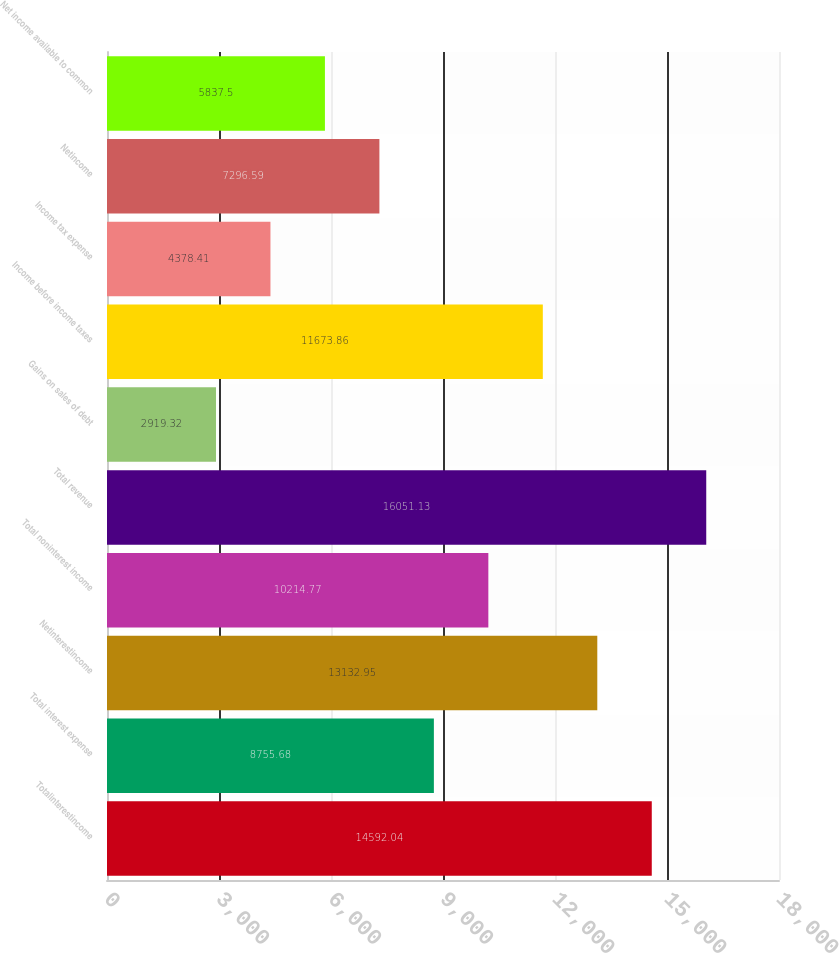Convert chart to OTSL. <chart><loc_0><loc_0><loc_500><loc_500><bar_chart><fcel>Totalinterestincome<fcel>Total interest expense<fcel>Netinterestincome<fcel>Total noninterest income<fcel>Total revenue<fcel>Gains on sales of debt<fcel>Income before income taxes<fcel>Income tax expense<fcel>Netincome<fcel>Net income available to common<nl><fcel>14592<fcel>8755.68<fcel>13133<fcel>10214.8<fcel>16051.1<fcel>2919.32<fcel>11673.9<fcel>4378.41<fcel>7296.59<fcel>5837.5<nl></chart> 